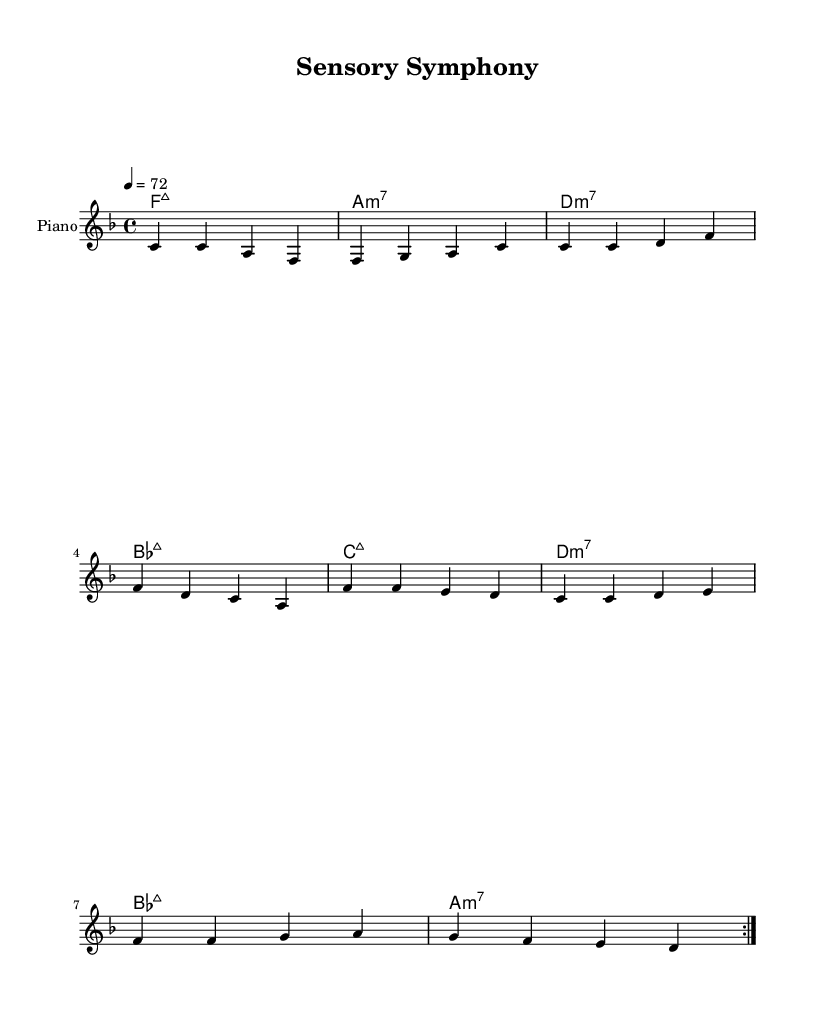What is the key signature of this music? The key signature is F major, which has one flat (B flat) indicated at the beginning of the staff.
Answer: F major What is the time signature of this piece? The time signature is 4/4, which means there are four beats in each measure, and each beat is a quarter note.
Answer: 4/4 What is the tempo marking for this music? The tempo marking is 72 beats per minute, as indicated by "4 = 72" in the tempo directive.
Answer: 72 How many measures are repeated? The music indicates a repeat section with the "volta" marking, which signifies two measures are repeated in the structured format.
Answer: 2 What type of chords are predominantly used in this piece? The chords used are predominantly seventh chords, which are indicated by the suffix (maj7 or m7) next to the root notes.
Answer: Seventh chords Explain the relationship between the melody and the chords used. The melody consists of notes that are often part of the chords indicated above it, showing a functional harmony typical in R&B music. This relationship enhances the emotional quality and smoothness in the harmony.
Answer: Melodic-harmonic relationship How does the structure of this sheet music align with typical Rhythm and Blues style? R&B often features introspective lyrics supported by smooth harmonies and repetitive chord progressions, which are evident here. The combination of the chord structure with reflective melodies captures the essence of R&B.
Answer: Smooth harmonies 